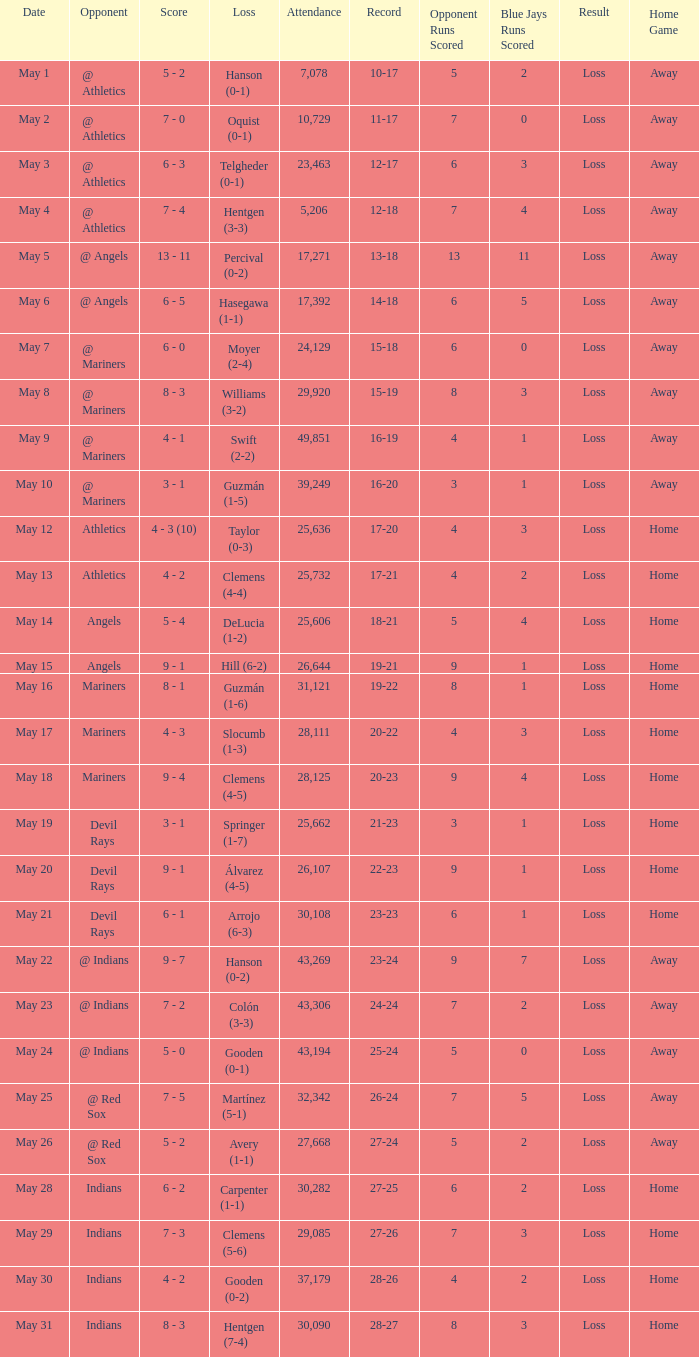When the record is 16-20 and attendance is greater than 32,342, what is the score? 3 - 1. 